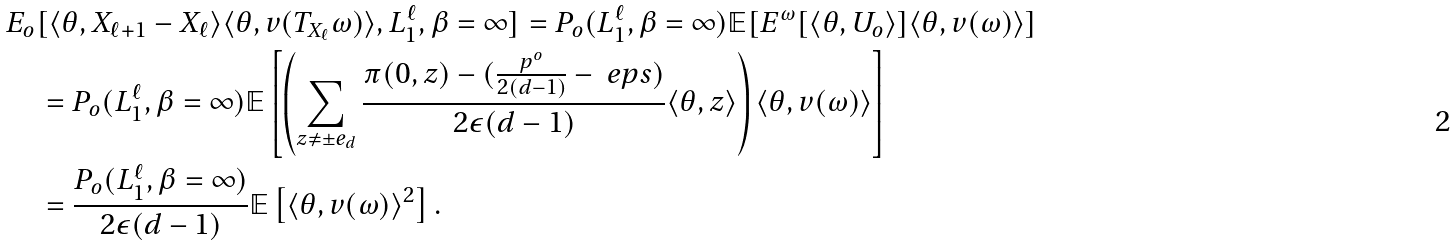<formula> <loc_0><loc_0><loc_500><loc_500>& E _ { o } [ \langle \theta , X _ { \ell + 1 } - X _ { \ell } \rangle \langle \theta , v ( T _ { X _ { \ell } } \omega ) \rangle , L _ { 1 } ^ { \ell } , \beta = \infty ] = P _ { o } ( L _ { 1 } ^ { \ell } , \beta = \infty ) \mathbb { E } [ E ^ { \omega } [ \langle \theta , U _ { o } \rangle ] \langle \theta , v ( \omega ) \rangle ] \\ & \quad = P _ { o } ( L _ { 1 } ^ { \ell } , \beta = \infty ) \mathbb { E } \left [ \left ( \sum _ { z \neq \pm e _ { d } } \frac { \pi ( 0 , z ) - ( \frac { p ^ { o } } { 2 ( d - 1 ) } - \ e p s ) } { 2 \epsilon ( d - 1 ) } \langle \theta , z \rangle \right ) \langle \theta , v ( \omega ) \rangle \right ] \\ & \quad = \frac { P _ { o } ( L _ { 1 } ^ { \ell } , \beta = \infty ) } { 2 \epsilon ( d - 1 ) } \mathbb { E } \left [ \langle \theta , v ( \omega ) \rangle ^ { 2 } \right ] .</formula> 